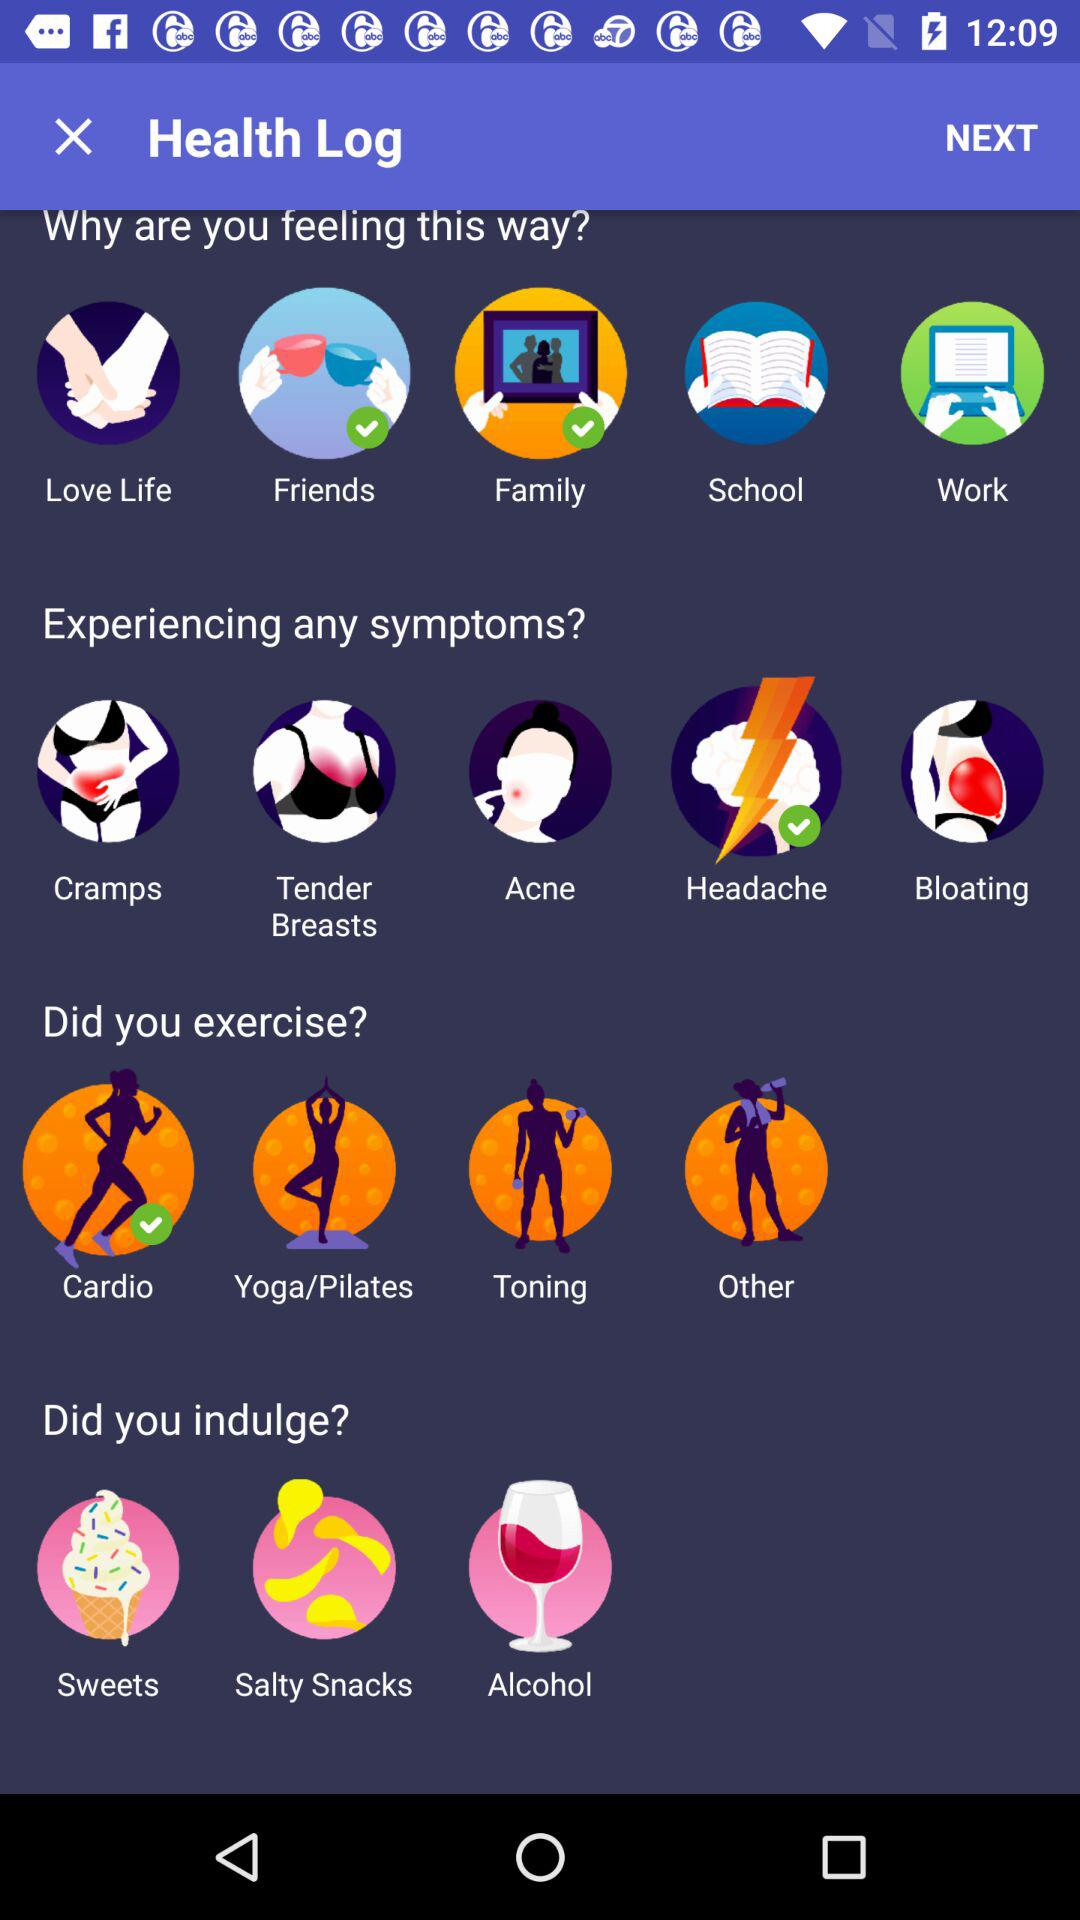What's the selected exercise by the user? The selected exercise is "Cardio". 